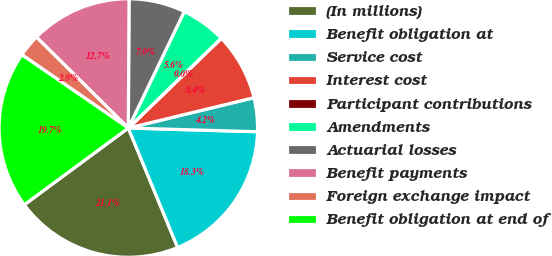<chart> <loc_0><loc_0><loc_500><loc_500><pie_chart><fcel>(In millions)<fcel>Benefit obligation at<fcel>Service cost<fcel>Interest cost<fcel>Participant contributions<fcel>Amendments<fcel>Actuarial losses<fcel>Benefit payments<fcel>Foreign exchange impact<fcel>Benefit obligation at end of<nl><fcel>21.12%<fcel>18.31%<fcel>4.23%<fcel>8.45%<fcel>0.01%<fcel>5.64%<fcel>7.04%<fcel>12.67%<fcel>2.82%<fcel>19.71%<nl></chart> 